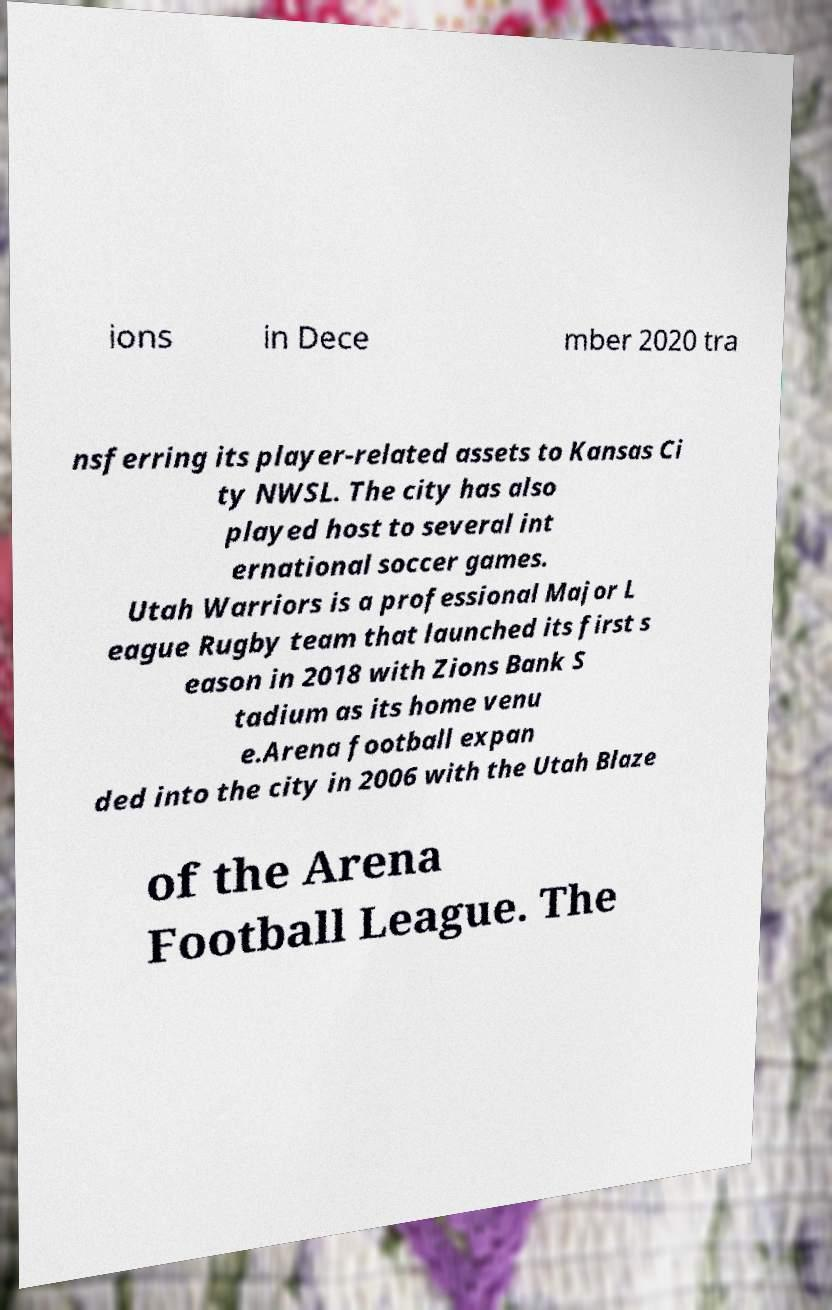I need the written content from this picture converted into text. Can you do that? ions in Dece mber 2020 tra nsferring its player-related assets to Kansas Ci ty NWSL. The city has also played host to several int ernational soccer games. Utah Warriors is a professional Major L eague Rugby team that launched its first s eason in 2018 with Zions Bank S tadium as its home venu e.Arena football expan ded into the city in 2006 with the Utah Blaze of the Arena Football League. The 